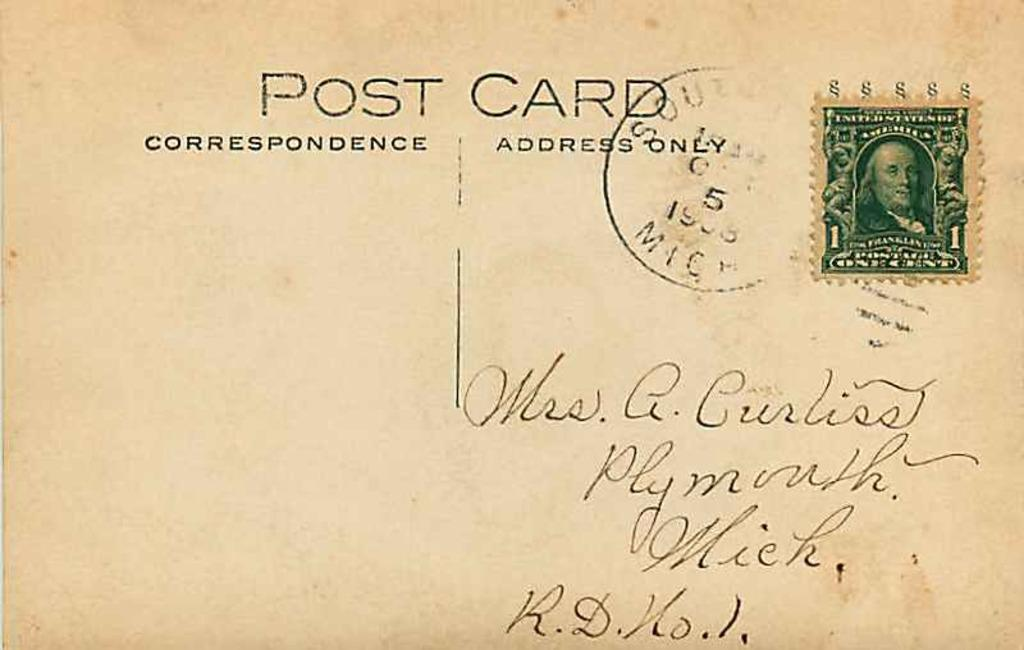<image>
Present a compact description of the photo's key features. Mrs. Curliss once sent a postcard from Plymouth, Michigan. 